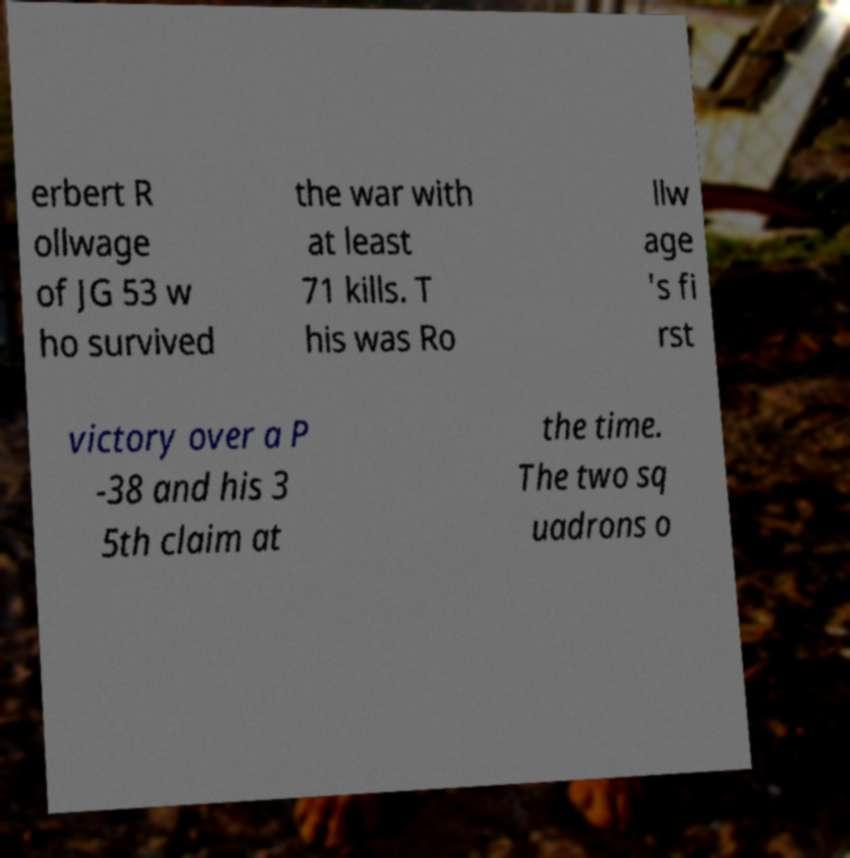Please identify and transcribe the text found in this image. erbert R ollwage of JG 53 w ho survived the war with at least 71 kills. T his was Ro llw age 's fi rst victory over a P -38 and his 3 5th claim at the time. The two sq uadrons o 